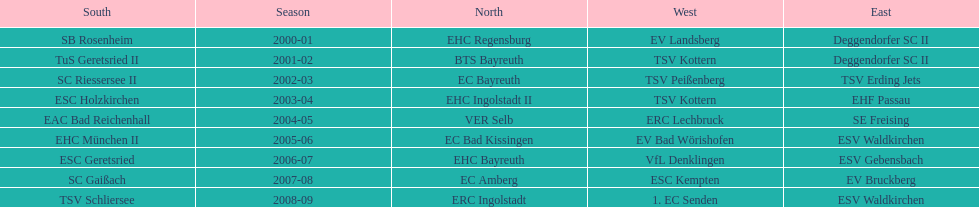Starting with the 2007 - 08 season, does ecs kempten appear in any of the previous years? No. I'm looking to parse the entire table for insights. Could you assist me with that? {'header': ['South', 'Season', 'North', 'West', 'East'], 'rows': [['SB Rosenheim', '2000-01', 'EHC Regensburg', 'EV Landsberg', 'Deggendorfer SC II'], ['TuS Geretsried II', '2001-02', 'BTS Bayreuth', 'TSV Kottern', 'Deggendorfer SC II'], ['SC Riessersee II', '2002-03', 'EC Bayreuth', 'TSV Peißenberg', 'TSV Erding Jets'], ['ESC Holzkirchen', '2003-04', 'EHC Ingolstadt II', 'TSV Kottern', 'EHF Passau'], ['EAC Bad Reichenhall', '2004-05', 'VER Selb', 'ERC Lechbruck', 'SE Freising'], ['EHC München II', '2005-06', 'EC Bad Kissingen', 'EV Bad Wörishofen', 'ESV Waldkirchen'], ['ESC Geretsried', '2006-07', 'EHC Bayreuth', 'VfL Denklingen', 'ESV Gebensbach'], ['SC Gaißach', '2007-08', 'EC Amberg', 'ESC Kempten', 'EV Bruckberg'], ['TSV Schliersee', '2008-09', 'ERC Ingolstadt', '1. EC Senden', 'ESV Waldkirchen']]} 